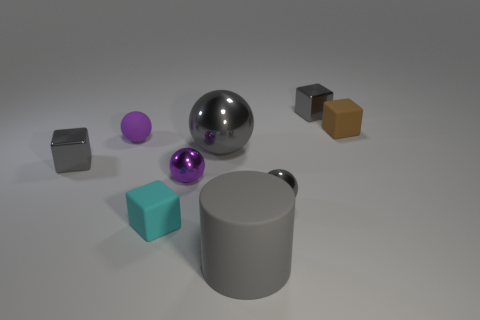Subtract all tiny cyan cubes. How many cubes are left? 3 Subtract all cylinders. How many objects are left? 8 Subtract 2 spheres. How many spheres are left? 2 Subtract all gray spheres. Subtract all green cylinders. How many spheres are left? 2 Subtract all yellow spheres. How many brown blocks are left? 1 Subtract all tiny purple rubber blocks. Subtract all small cyan cubes. How many objects are left? 8 Add 4 rubber spheres. How many rubber spheres are left? 5 Add 5 tiny purple shiny spheres. How many tiny purple shiny spheres exist? 6 Subtract all purple balls. How many balls are left? 2 Subtract 0 red spheres. How many objects are left? 9 